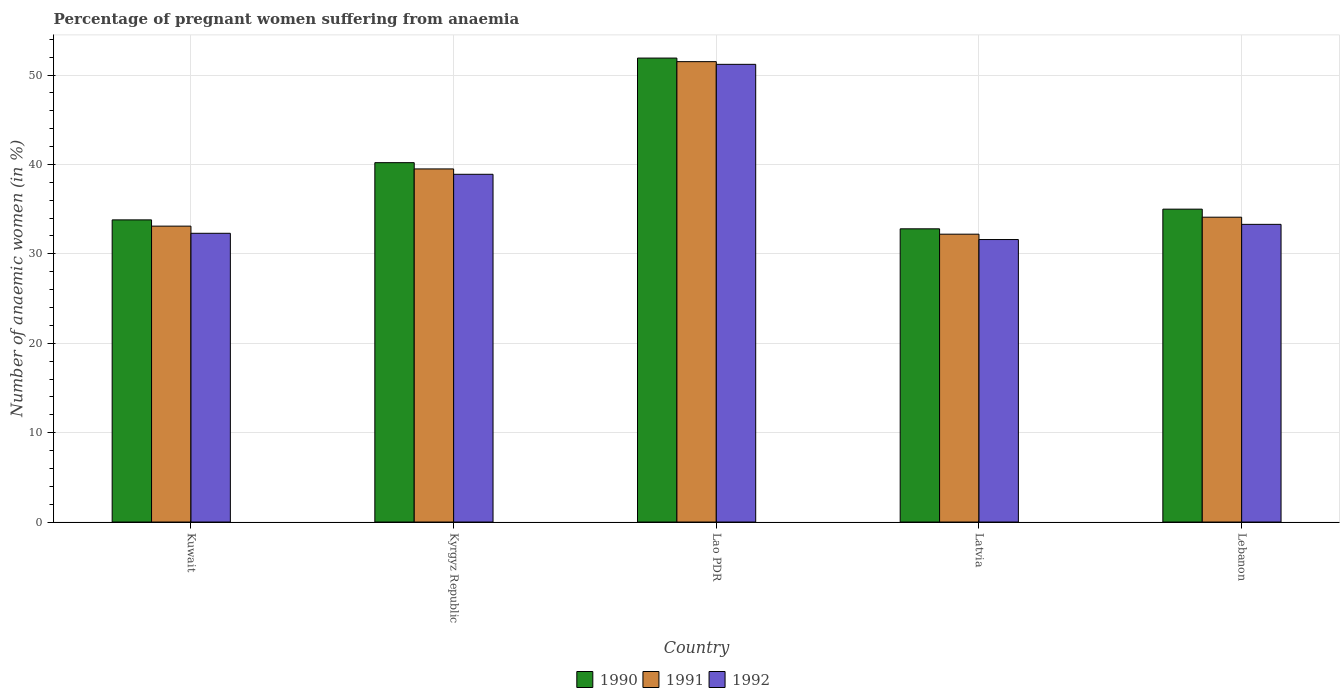How many different coloured bars are there?
Make the answer very short. 3. How many bars are there on the 4th tick from the left?
Give a very brief answer. 3. What is the label of the 3rd group of bars from the left?
Keep it short and to the point. Lao PDR. What is the number of anaemic women in 1992 in Lao PDR?
Provide a short and direct response. 51.2. Across all countries, what is the maximum number of anaemic women in 1990?
Give a very brief answer. 51.9. Across all countries, what is the minimum number of anaemic women in 1990?
Keep it short and to the point. 32.8. In which country was the number of anaemic women in 1991 maximum?
Offer a terse response. Lao PDR. In which country was the number of anaemic women in 1990 minimum?
Offer a very short reply. Latvia. What is the total number of anaemic women in 1992 in the graph?
Your answer should be compact. 187.3. What is the difference between the number of anaemic women in 1992 in Kuwait and the number of anaemic women in 1990 in Lebanon?
Give a very brief answer. -2.7. What is the average number of anaemic women in 1992 per country?
Make the answer very short. 37.46. What is the difference between the number of anaemic women of/in 1992 and number of anaemic women of/in 1990 in Kyrgyz Republic?
Ensure brevity in your answer.  -1.3. What is the ratio of the number of anaemic women in 1991 in Kuwait to that in Kyrgyz Republic?
Give a very brief answer. 0.84. Is the difference between the number of anaemic women in 1992 in Kyrgyz Republic and Latvia greater than the difference between the number of anaemic women in 1990 in Kyrgyz Republic and Latvia?
Your response must be concise. No. What is the difference between the highest and the second highest number of anaemic women in 1992?
Ensure brevity in your answer.  -17.9. What is the difference between the highest and the lowest number of anaemic women in 1992?
Your answer should be very brief. 19.6. In how many countries, is the number of anaemic women in 1992 greater than the average number of anaemic women in 1992 taken over all countries?
Your response must be concise. 2. What is the difference between two consecutive major ticks on the Y-axis?
Your answer should be compact. 10. Are the values on the major ticks of Y-axis written in scientific E-notation?
Your answer should be compact. No. Does the graph contain any zero values?
Give a very brief answer. No. Does the graph contain grids?
Your response must be concise. Yes. Where does the legend appear in the graph?
Provide a succinct answer. Bottom center. How many legend labels are there?
Give a very brief answer. 3. What is the title of the graph?
Your answer should be very brief. Percentage of pregnant women suffering from anaemia. Does "1988" appear as one of the legend labels in the graph?
Keep it short and to the point. No. What is the label or title of the Y-axis?
Your answer should be very brief. Number of anaemic women (in %). What is the Number of anaemic women (in %) of 1990 in Kuwait?
Provide a short and direct response. 33.8. What is the Number of anaemic women (in %) in 1991 in Kuwait?
Your answer should be compact. 33.1. What is the Number of anaemic women (in %) of 1992 in Kuwait?
Give a very brief answer. 32.3. What is the Number of anaemic women (in %) in 1990 in Kyrgyz Republic?
Make the answer very short. 40.2. What is the Number of anaemic women (in %) in 1991 in Kyrgyz Republic?
Provide a succinct answer. 39.5. What is the Number of anaemic women (in %) in 1992 in Kyrgyz Republic?
Provide a short and direct response. 38.9. What is the Number of anaemic women (in %) in 1990 in Lao PDR?
Ensure brevity in your answer.  51.9. What is the Number of anaemic women (in %) in 1991 in Lao PDR?
Ensure brevity in your answer.  51.5. What is the Number of anaemic women (in %) of 1992 in Lao PDR?
Your answer should be compact. 51.2. What is the Number of anaemic women (in %) in 1990 in Latvia?
Offer a very short reply. 32.8. What is the Number of anaemic women (in %) of 1991 in Latvia?
Keep it short and to the point. 32.2. What is the Number of anaemic women (in %) of 1992 in Latvia?
Keep it short and to the point. 31.6. What is the Number of anaemic women (in %) in 1990 in Lebanon?
Offer a very short reply. 35. What is the Number of anaemic women (in %) in 1991 in Lebanon?
Your answer should be compact. 34.1. What is the Number of anaemic women (in %) in 1992 in Lebanon?
Give a very brief answer. 33.3. Across all countries, what is the maximum Number of anaemic women (in %) in 1990?
Your answer should be compact. 51.9. Across all countries, what is the maximum Number of anaemic women (in %) of 1991?
Your answer should be compact. 51.5. Across all countries, what is the maximum Number of anaemic women (in %) in 1992?
Offer a very short reply. 51.2. Across all countries, what is the minimum Number of anaemic women (in %) of 1990?
Provide a short and direct response. 32.8. Across all countries, what is the minimum Number of anaemic women (in %) of 1991?
Provide a short and direct response. 32.2. Across all countries, what is the minimum Number of anaemic women (in %) in 1992?
Give a very brief answer. 31.6. What is the total Number of anaemic women (in %) of 1990 in the graph?
Offer a very short reply. 193.7. What is the total Number of anaemic women (in %) of 1991 in the graph?
Provide a succinct answer. 190.4. What is the total Number of anaemic women (in %) of 1992 in the graph?
Give a very brief answer. 187.3. What is the difference between the Number of anaemic women (in %) in 1990 in Kuwait and that in Kyrgyz Republic?
Make the answer very short. -6.4. What is the difference between the Number of anaemic women (in %) in 1991 in Kuwait and that in Kyrgyz Republic?
Offer a very short reply. -6.4. What is the difference between the Number of anaemic women (in %) in 1990 in Kuwait and that in Lao PDR?
Provide a succinct answer. -18.1. What is the difference between the Number of anaemic women (in %) of 1991 in Kuwait and that in Lao PDR?
Offer a very short reply. -18.4. What is the difference between the Number of anaemic women (in %) in 1992 in Kuwait and that in Lao PDR?
Your answer should be very brief. -18.9. What is the difference between the Number of anaemic women (in %) in 1992 in Kuwait and that in Latvia?
Your answer should be very brief. 0.7. What is the difference between the Number of anaemic women (in %) in 1992 in Kyrgyz Republic and that in Latvia?
Your answer should be very brief. 7.3. What is the difference between the Number of anaemic women (in %) of 1990 in Kyrgyz Republic and that in Lebanon?
Keep it short and to the point. 5.2. What is the difference between the Number of anaemic women (in %) in 1991 in Kyrgyz Republic and that in Lebanon?
Make the answer very short. 5.4. What is the difference between the Number of anaemic women (in %) in 1992 in Kyrgyz Republic and that in Lebanon?
Ensure brevity in your answer.  5.6. What is the difference between the Number of anaemic women (in %) in 1991 in Lao PDR and that in Latvia?
Provide a succinct answer. 19.3. What is the difference between the Number of anaemic women (in %) of 1992 in Lao PDR and that in Latvia?
Give a very brief answer. 19.6. What is the difference between the Number of anaemic women (in %) in 1991 in Lao PDR and that in Lebanon?
Make the answer very short. 17.4. What is the difference between the Number of anaemic women (in %) of 1992 in Lao PDR and that in Lebanon?
Your answer should be compact. 17.9. What is the difference between the Number of anaemic women (in %) of 1992 in Latvia and that in Lebanon?
Offer a terse response. -1.7. What is the difference between the Number of anaemic women (in %) of 1991 in Kuwait and the Number of anaemic women (in %) of 1992 in Kyrgyz Republic?
Your answer should be compact. -5.8. What is the difference between the Number of anaemic women (in %) in 1990 in Kuwait and the Number of anaemic women (in %) in 1991 in Lao PDR?
Your answer should be compact. -17.7. What is the difference between the Number of anaemic women (in %) in 1990 in Kuwait and the Number of anaemic women (in %) in 1992 in Lao PDR?
Offer a very short reply. -17.4. What is the difference between the Number of anaemic women (in %) in 1991 in Kuwait and the Number of anaemic women (in %) in 1992 in Lao PDR?
Your answer should be compact. -18.1. What is the difference between the Number of anaemic women (in %) of 1990 in Kyrgyz Republic and the Number of anaemic women (in %) of 1991 in Lao PDR?
Ensure brevity in your answer.  -11.3. What is the difference between the Number of anaemic women (in %) in 1990 in Kyrgyz Republic and the Number of anaemic women (in %) in 1992 in Lao PDR?
Make the answer very short. -11. What is the difference between the Number of anaemic women (in %) in 1990 in Kyrgyz Republic and the Number of anaemic women (in %) in 1992 in Latvia?
Ensure brevity in your answer.  8.6. What is the difference between the Number of anaemic women (in %) of 1990 in Kyrgyz Republic and the Number of anaemic women (in %) of 1992 in Lebanon?
Make the answer very short. 6.9. What is the difference between the Number of anaemic women (in %) in 1990 in Lao PDR and the Number of anaemic women (in %) in 1991 in Latvia?
Offer a very short reply. 19.7. What is the difference between the Number of anaemic women (in %) in 1990 in Lao PDR and the Number of anaemic women (in %) in 1992 in Latvia?
Offer a very short reply. 20.3. What is the difference between the Number of anaemic women (in %) of 1991 in Lao PDR and the Number of anaemic women (in %) of 1992 in Latvia?
Your answer should be compact. 19.9. What is the difference between the Number of anaemic women (in %) of 1990 in Lao PDR and the Number of anaemic women (in %) of 1991 in Lebanon?
Ensure brevity in your answer.  17.8. What is the difference between the Number of anaemic women (in %) in 1990 in Lao PDR and the Number of anaemic women (in %) in 1992 in Lebanon?
Keep it short and to the point. 18.6. What is the difference between the Number of anaemic women (in %) of 1990 in Latvia and the Number of anaemic women (in %) of 1991 in Lebanon?
Offer a terse response. -1.3. What is the difference between the Number of anaemic women (in %) of 1990 in Latvia and the Number of anaemic women (in %) of 1992 in Lebanon?
Your response must be concise. -0.5. What is the difference between the Number of anaemic women (in %) of 1991 in Latvia and the Number of anaemic women (in %) of 1992 in Lebanon?
Provide a succinct answer. -1.1. What is the average Number of anaemic women (in %) of 1990 per country?
Make the answer very short. 38.74. What is the average Number of anaemic women (in %) in 1991 per country?
Offer a terse response. 38.08. What is the average Number of anaemic women (in %) in 1992 per country?
Provide a succinct answer. 37.46. What is the difference between the Number of anaemic women (in %) in 1990 and Number of anaemic women (in %) in 1991 in Kuwait?
Ensure brevity in your answer.  0.7. What is the difference between the Number of anaemic women (in %) in 1990 and Number of anaemic women (in %) in 1992 in Kuwait?
Your response must be concise. 1.5. What is the difference between the Number of anaemic women (in %) in 1991 and Number of anaemic women (in %) in 1992 in Kuwait?
Offer a very short reply. 0.8. What is the difference between the Number of anaemic women (in %) in 1990 and Number of anaemic women (in %) in 1992 in Kyrgyz Republic?
Make the answer very short. 1.3. What is the difference between the Number of anaemic women (in %) in 1991 and Number of anaemic women (in %) in 1992 in Kyrgyz Republic?
Provide a short and direct response. 0.6. What is the difference between the Number of anaemic women (in %) of 1990 and Number of anaemic women (in %) of 1991 in Lao PDR?
Keep it short and to the point. 0.4. What is the difference between the Number of anaemic women (in %) of 1991 and Number of anaemic women (in %) of 1992 in Lao PDR?
Provide a short and direct response. 0.3. What is the difference between the Number of anaemic women (in %) in 1990 and Number of anaemic women (in %) in 1991 in Lebanon?
Ensure brevity in your answer.  0.9. What is the difference between the Number of anaemic women (in %) in 1990 and Number of anaemic women (in %) in 1992 in Lebanon?
Keep it short and to the point. 1.7. What is the difference between the Number of anaemic women (in %) of 1991 and Number of anaemic women (in %) of 1992 in Lebanon?
Make the answer very short. 0.8. What is the ratio of the Number of anaemic women (in %) in 1990 in Kuwait to that in Kyrgyz Republic?
Provide a short and direct response. 0.84. What is the ratio of the Number of anaemic women (in %) in 1991 in Kuwait to that in Kyrgyz Republic?
Provide a short and direct response. 0.84. What is the ratio of the Number of anaemic women (in %) of 1992 in Kuwait to that in Kyrgyz Republic?
Offer a terse response. 0.83. What is the ratio of the Number of anaemic women (in %) in 1990 in Kuwait to that in Lao PDR?
Offer a terse response. 0.65. What is the ratio of the Number of anaemic women (in %) of 1991 in Kuwait to that in Lao PDR?
Ensure brevity in your answer.  0.64. What is the ratio of the Number of anaemic women (in %) of 1992 in Kuwait to that in Lao PDR?
Ensure brevity in your answer.  0.63. What is the ratio of the Number of anaemic women (in %) of 1990 in Kuwait to that in Latvia?
Your answer should be compact. 1.03. What is the ratio of the Number of anaemic women (in %) in 1991 in Kuwait to that in Latvia?
Give a very brief answer. 1.03. What is the ratio of the Number of anaemic women (in %) of 1992 in Kuwait to that in Latvia?
Make the answer very short. 1.02. What is the ratio of the Number of anaemic women (in %) of 1990 in Kuwait to that in Lebanon?
Provide a short and direct response. 0.97. What is the ratio of the Number of anaemic women (in %) in 1991 in Kuwait to that in Lebanon?
Your answer should be very brief. 0.97. What is the ratio of the Number of anaemic women (in %) of 1990 in Kyrgyz Republic to that in Lao PDR?
Your response must be concise. 0.77. What is the ratio of the Number of anaemic women (in %) in 1991 in Kyrgyz Republic to that in Lao PDR?
Keep it short and to the point. 0.77. What is the ratio of the Number of anaemic women (in %) of 1992 in Kyrgyz Republic to that in Lao PDR?
Give a very brief answer. 0.76. What is the ratio of the Number of anaemic women (in %) of 1990 in Kyrgyz Republic to that in Latvia?
Your response must be concise. 1.23. What is the ratio of the Number of anaemic women (in %) of 1991 in Kyrgyz Republic to that in Latvia?
Your answer should be compact. 1.23. What is the ratio of the Number of anaemic women (in %) in 1992 in Kyrgyz Republic to that in Latvia?
Ensure brevity in your answer.  1.23. What is the ratio of the Number of anaemic women (in %) of 1990 in Kyrgyz Republic to that in Lebanon?
Give a very brief answer. 1.15. What is the ratio of the Number of anaemic women (in %) in 1991 in Kyrgyz Republic to that in Lebanon?
Your answer should be compact. 1.16. What is the ratio of the Number of anaemic women (in %) of 1992 in Kyrgyz Republic to that in Lebanon?
Your answer should be very brief. 1.17. What is the ratio of the Number of anaemic women (in %) of 1990 in Lao PDR to that in Latvia?
Offer a terse response. 1.58. What is the ratio of the Number of anaemic women (in %) of 1991 in Lao PDR to that in Latvia?
Your answer should be very brief. 1.6. What is the ratio of the Number of anaemic women (in %) of 1992 in Lao PDR to that in Latvia?
Keep it short and to the point. 1.62. What is the ratio of the Number of anaemic women (in %) of 1990 in Lao PDR to that in Lebanon?
Keep it short and to the point. 1.48. What is the ratio of the Number of anaemic women (in %) in 1991 in Lao PDR to that in Lebanon?
Offer a very short reply. 1.51. What is the ratio of the Number of anaemic women (in %) in 1992 in Lao PDR to that in Lebanon?
Provide a short and direct response. 1.54. What is the ratio of the Number of anaemic women (in %) in 1990 in Latvia to that in Lebanon?
Offer a very short reply. 0.94. What is the ratio of the Number of anaemic women (in %) in 1991 in Latvia to that in Lebanon?
Offer a terse response. 0.94. What is the ratio of the Number of anaemic women (in %) of 1992 in Latvia to that in Lebanon?
Ensure brevity in your answer.  0.95. What is the difference between the highest and the second highest Number of anaemic women (in %) in 1990?
Offer a very short reply. 11.7. What is the difference between the highest and the lowest Number of anaemic women (in %) of 1991?
Offer a very short reply. 19.3. What is the difference between the highest and the lowest Number of anaemic women (in %) in 1992?
Give a very brief answer. 19.6. 